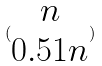Convert formula to latex. <formula><loc_0><loc_0><loc_500><loc_500>( \begin{matrix} n \\ 0 . 5 1 n \end{matrix} )</formula> 